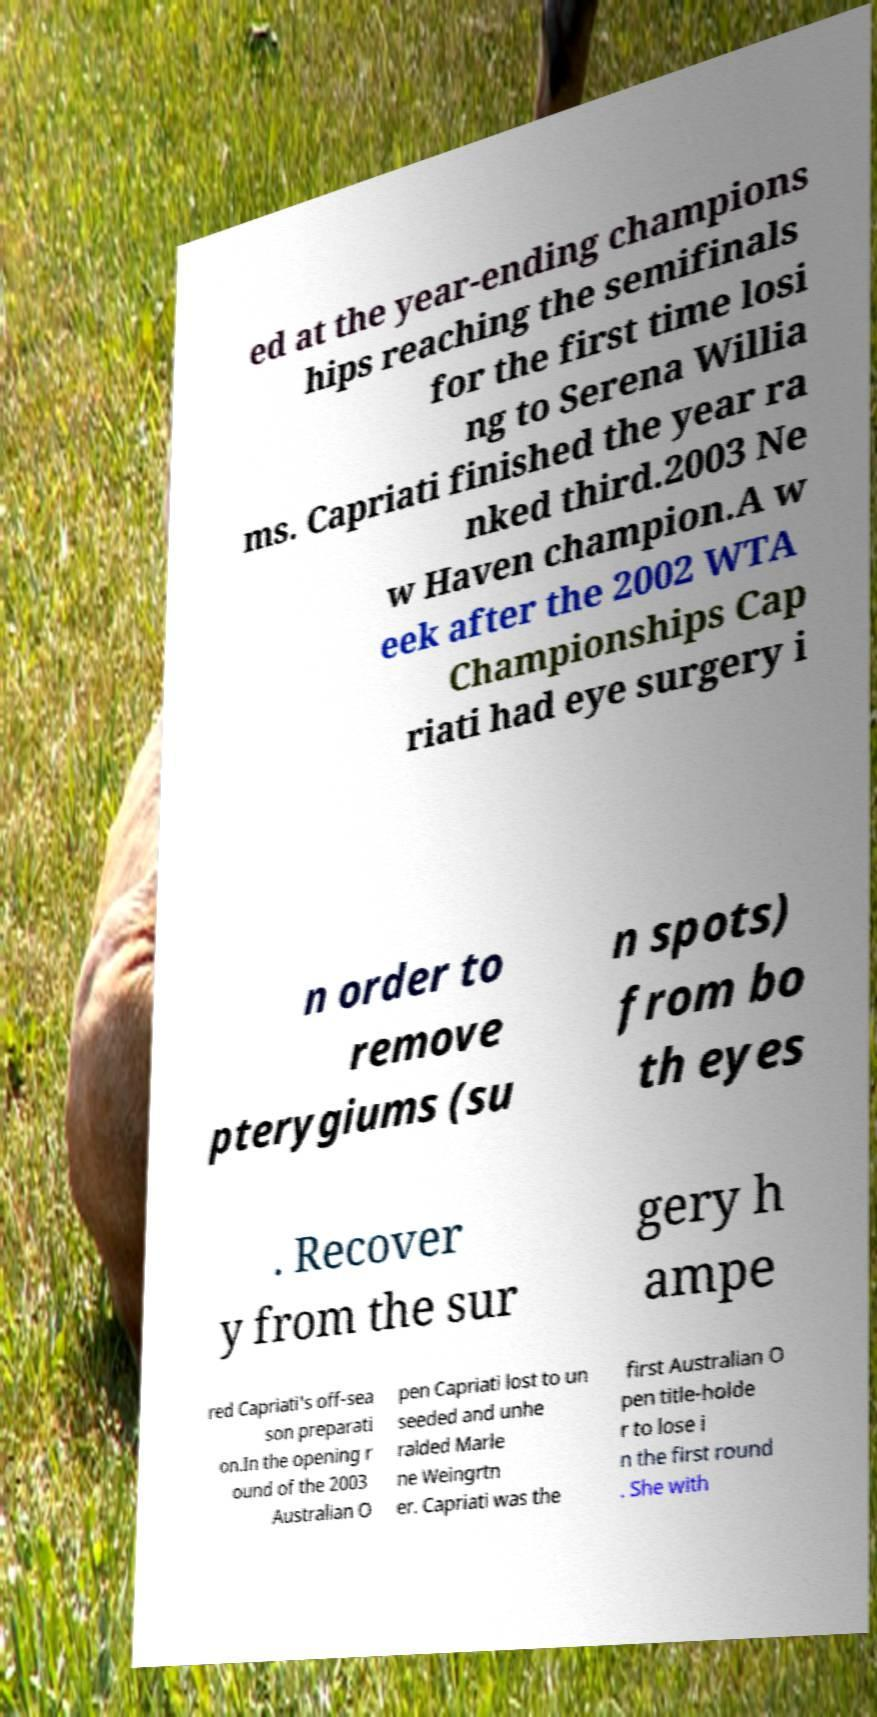Could you extract and type out the text from this image? ed at the year-ending champions hips reaching the semifinals for the first time losi ng to Serena Willia ms. Capriati finished the year ra nked third.2003 Ne w Haven champion.A w eek after the 2002 WTA Championships Cap riati had eye surgery i n order to remove pterygiums (su n spots) from bo th eyes . Recover y from the sur gery h ampe red Capriati's off-sea son preparati on.In the opening r ound of the 2003 Australian O pen Capriati lost to un seeded and unhe ralded Marle ne Weingrtn er. Capriati was the first Australian O pen title-holde r to lose i n the first round . She with 